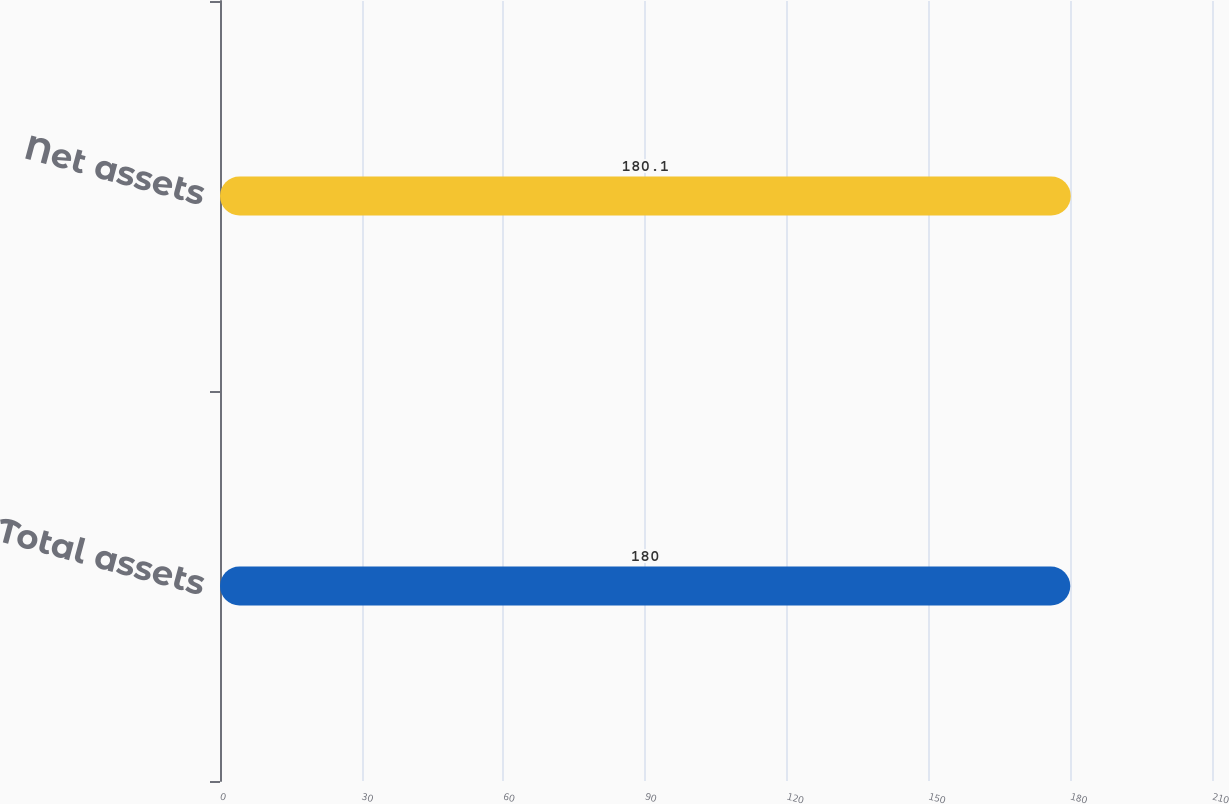<chart> <loc_0><loc_0><loc_500><loc_500><bar_chart><fcel>Total assets<fcel>Net assets<nl><fcel>180<fcel>180.1<nl></chart> 